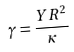<formula> <loc_0><loc_0><loc_500><loc_500>\gamma = \frac { Y R ^ { 2 } } { \kappa }</formula> 